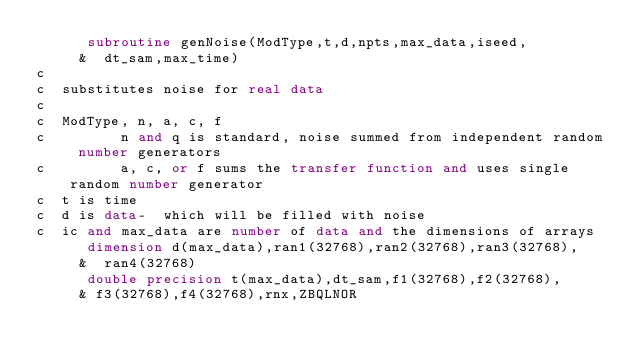<code> <loc_0><loc_0><loc_500><loc_500><_FORTRAN_>      subroutine genNoise(ModType,t,d,npts,max_data,iseed,
     &  dt_sam,max_time)
c
c  substitutes noise for real data
c
c  ModType, n, a, c, f
c         n and q is standard, noise summed from independent random number generators
c         a, c, or f sums the transfer function and uses single random number generator
c  t is time
c  d is data-  which will be filled with noise
c  ic and max_data are number of data and the dimensions of arrays
      dimension d(max_data),ran1(32768),ran2(32768),ran3(32768),
     &  ran4(32768)
      double precision t(max_data),dt_sam,f1(32768),f2(32768),
     & f3(32768),f4(32768),rnx,ZBQLNOR</code> 